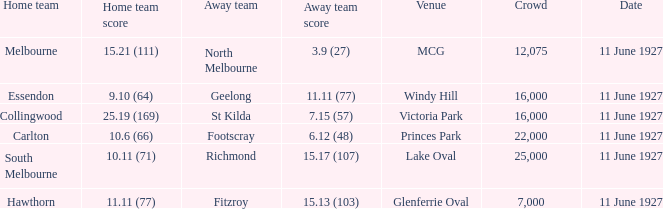What was the overall attendance in all the crowds at the mcg site? 12075.0. 